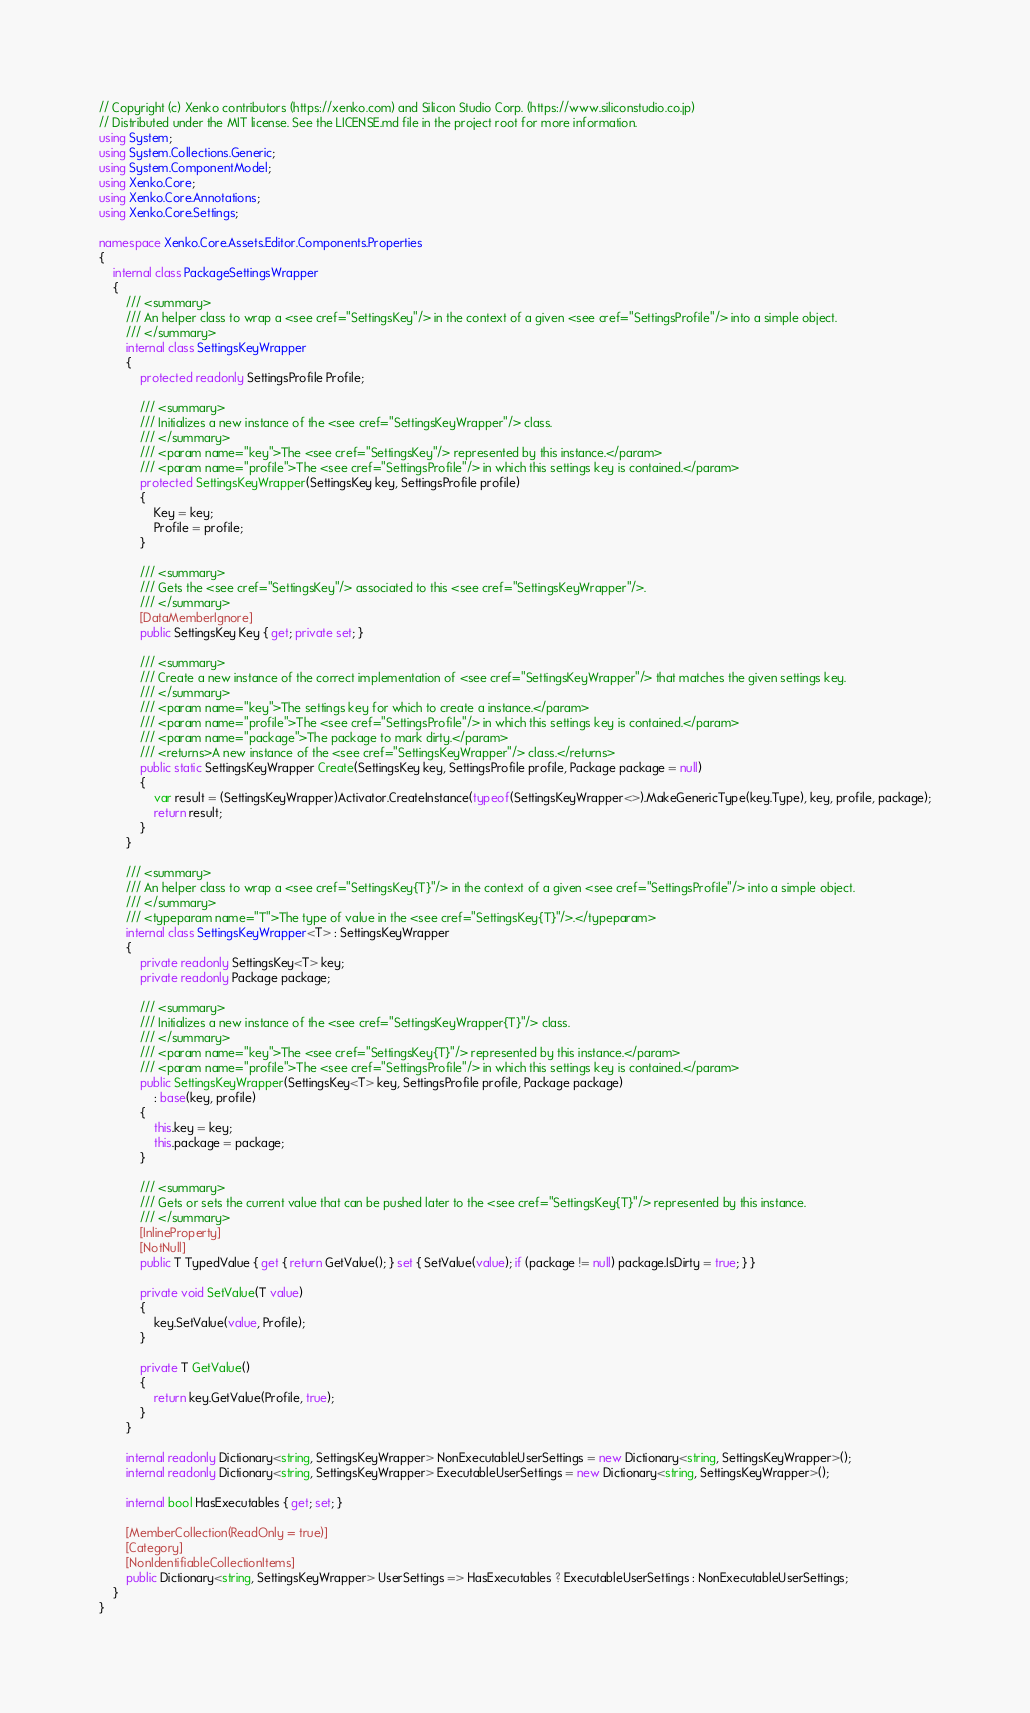Convert code to text. <code><loc_0><loc_0><loc_500><loc_500><_C#_>// Copyright (c) Xenko contributors (https://xenko.com) and Silicon Studio Corp. (https://www.siliconstudio.co.jp)
// Distributed under the MIT license. See the LICENSE.md file in the project root for more information.
using System;
using System.Collections.Generic;
using System.ComponentModel;
using Xenko.Core;
using Xenko.Core.Annotations;
using Xenko.Core.Settings;

namespace Xenko.Core.Assets.Editor.Components.Properties
{
    internal class PackageSettingsWrapper
    {
        /// <summary>
        /// An helper class to wrap a <see cref="SettingsKey"/> in the context of a given <see cref="SettingsProfile"/> into a simple object.
        /// </summary>
        internal class SettingsKeyWrapper
        {
            protected readonly SettingsProfile Profile;

            /// <summary>
            /// Initializes a new instance of the <see cref="SettingsKeyWrapper"/> class.
            /// </summary>
            /// <param name="key">The <see cref="SettingsKey"/> represented by this instance.</param>
            /// <param name="profile">The <see cref="SettingsProfile"/> in which this settings key is contained.</param>
            protected SettingsKeyWrapper(SettingsKey key, SettingsProfile profile)
            {
                Key = key;
                Profile = profile;
            }

            /// <summary>
            /// Gets the <see cref="SettingsKey"/> associated to this <see cref="SettingsKeyWrapper"/>.
            /// </summary>
            [DataMemberIgnore]
            public SettingsKey Key { get; private set; }

            /// <summary>
            /// Create a new instance of the correct implementation of <see cref="SettingsKeyWrapper"/> that matches the given settings key.
            /// </summary>
            /// <param name="key">The settings key for which to create a instance.</param>
            /// <param name="profile">The <see cref="SettingsProfile"/> in which this settings key is contained.</param>
            /// <param name="package">The package to mark dirty.</param>
            /// <returns>A new instance of the <see cref="SettingsKeyWrapper"/> class.</returns>
            public static SettingsKeyWrapper Create(SettingsKey key, SettingsProfile profile, Package package = null)
            {
                var result = (SettingsKeyWrapper)Activator.CreateInstance(typeof(SettingsKeyWrapper<>).MakeGenericType(key.Type), key, profile, package);
                return result;
            }
        }

        /// <summary>
        /// An helper class to wrap a <see cref="SettingsKey{T}"/> in the context of a given <see cref="SettingsProfile"/> into a simple object.
        /// </summary>
        /// <typeparam name="T">The type of value in the <see cref="SettingsKey{T}"/>.</typeparam>
        internal class SettingsKeyWrapper<T> : SettingsKeyWrapper
        {
            private readonly SettingsKey<T> key;
            private readonly Package package;

            /// <summary>
            /// Initializes a new instance of the <see cref="SettingsKeyWrapper{T}"/> class.
            /// </summary>
            /// <param name="key">The <see cref="SettingsKey{T}"/> represented by this instance.</param>
            /// <param name="profile">The <see cref="SettingsProfile"/> in which this settings key is contained.</param>
            public SettingsKeyWrapper(SettingsKey<T> key, SettingsProfile profile, Package package)
                : base(key, profile)
            {
                this.key = key;
                this.package = package;
            }

            /// <summary>
            /// Gets or sets the current value that can be pushed later to the <see cref="SettingsKey{T}"/> represented by this instance.
            /// </summary>
            [InlineProperty]
            [NotNull]
            public T TypedValue { get { return GetValue(); } set { SetValue(value); if (package != null) package.IsDirty = true; } }
        
            private void SetValue(T value)
            {
                key.SetValue(value, Profile);
            }

            private T GetValue()
            {
                return key.GetValue(Profile, true);
            }
        }

        internal readonly Dictionary<string, SettingsKeyWrapper> NonExecutableUserSettings = new Dictionary<string, SettingsKeyWrapper>();
        internal readonly Dictionary<string, SettingsKeyWrapper> ExecutableUserSettings = new Dictionary<string, SettingsKeyWrapper>();

        internal bool HasExecutables { get; set; }

        [MemberCollection(ReadOnly = true)]
        [Category]
        [NonIdentifiableCollectionItems]
        public Dictionary<string, SettingsKeyWrapper> UserSettings => HasExecutables ? ExecutableUserSettings : NonExecutableUserSettings;
    }
}
</code> 